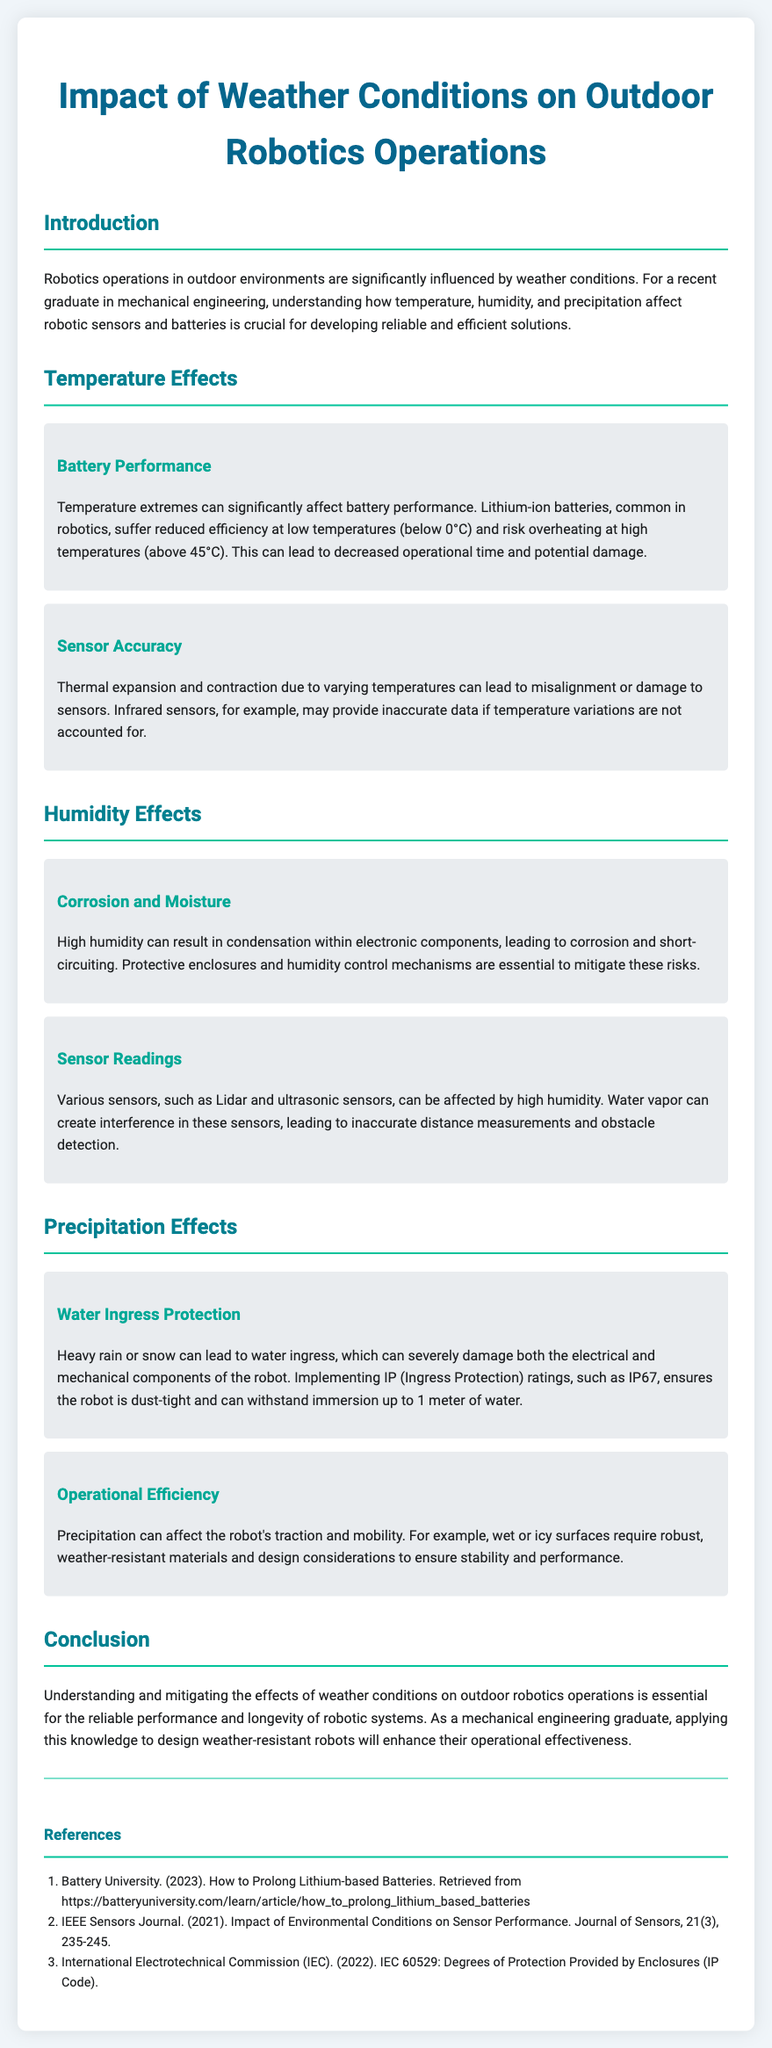What is the main topic of the document? The main topic of the document is the impact of weather conditions on outdoor robotics operations, as clearly indicated in the title.
Answer: Impact of Weather Conditions on Outdoor Robotics Operations What happens to lithium-ion batteries at low temperatures? The document states that lithium-ion batteries suffer reduced efficiency at low temperatures, specifically below 0 degrees Celsius.
Answer: Reduced efficiency below 0°C What effect does high humidity have on electronic components? According to the document, high humidity can cause condensation within electronic components, leading to corrosion and short-circuiting.
Answer: Corrosion and short-circuiting What IP rating is mentioned in relation to water ingress protection? The document refers to IP67 as the standard for ensuring protection against water ingress.
Answer: IP67 How does precipitation affect robot mobility? The document explains that precipitation can affect the robot's traction and stability on wet or icy surfaces.
Answer: Traction and stability What must be accounted for to ensure sensor accuracy in variable temperatures? The document mentions that thermal expansion and contraction must be accounted for to maintain sensor accuracy in varying temperatures.
Answer: Thermal expansion and contraction What is one design consideration for robots operating in wet conditions? The document suggests using robust, weather-resistant materials as a design consideration for robots operating in wet conditions.
Answer: Robust, weather-resistant materials Which type of sensors can be affected by high humidity? The document states that Lidar and ultrasonic sensors can be affected by high humidity conditions.
Answer: Lidar and ultrasonic sensors What is the consequence of temperature extremes on battery performance? The document indicates that temperature extremes can lead to decreased operational time and potential damage to the batteries.
Answer: Decreased operational time and potential damage 